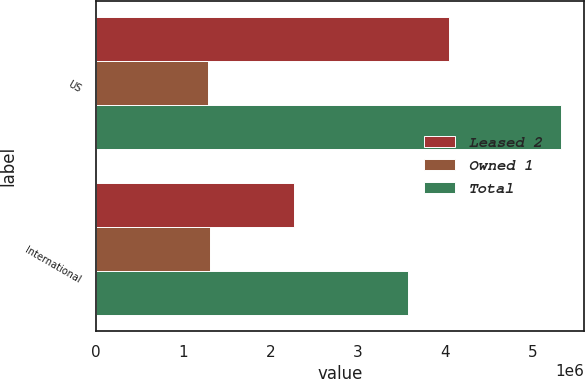<chart> <loc_0><loc_0><loc_500><loc_500><stacked_bar_chart><ecel><fcel>US<fcel>International<nl><fcel>Leased 2<fcel>4.043e+06<fcel>2.269e+06<nl><fcel>Owned 1<fcel>1.283e+06<fcel>1.304e+06<nl><fcel>Total<fcel>5.326e+06<fcel>3.573e+06<nl></chart> 